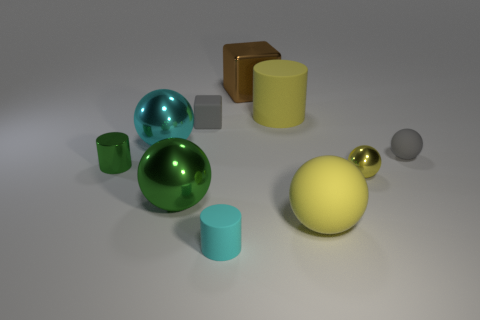Subtract all cyan spheres. How many spheres are left? 4 Subtract all large green spheres. How many spheres are left? 4 Subtract all blue spheres. Subtract all red cylinders. How many spheres are left? 5 Subtract all blocks. How many objects are left? 8 Add 3 blocks. How many blocks are left? 5 Add 2 green cylinders. How many green cylinders exist? 3 Subtract 0 blue blocks. How many objects are left? 10 Subtract all green metallic cylinders. Subtract all yellow rubber spheres. How many objects are left? 8 